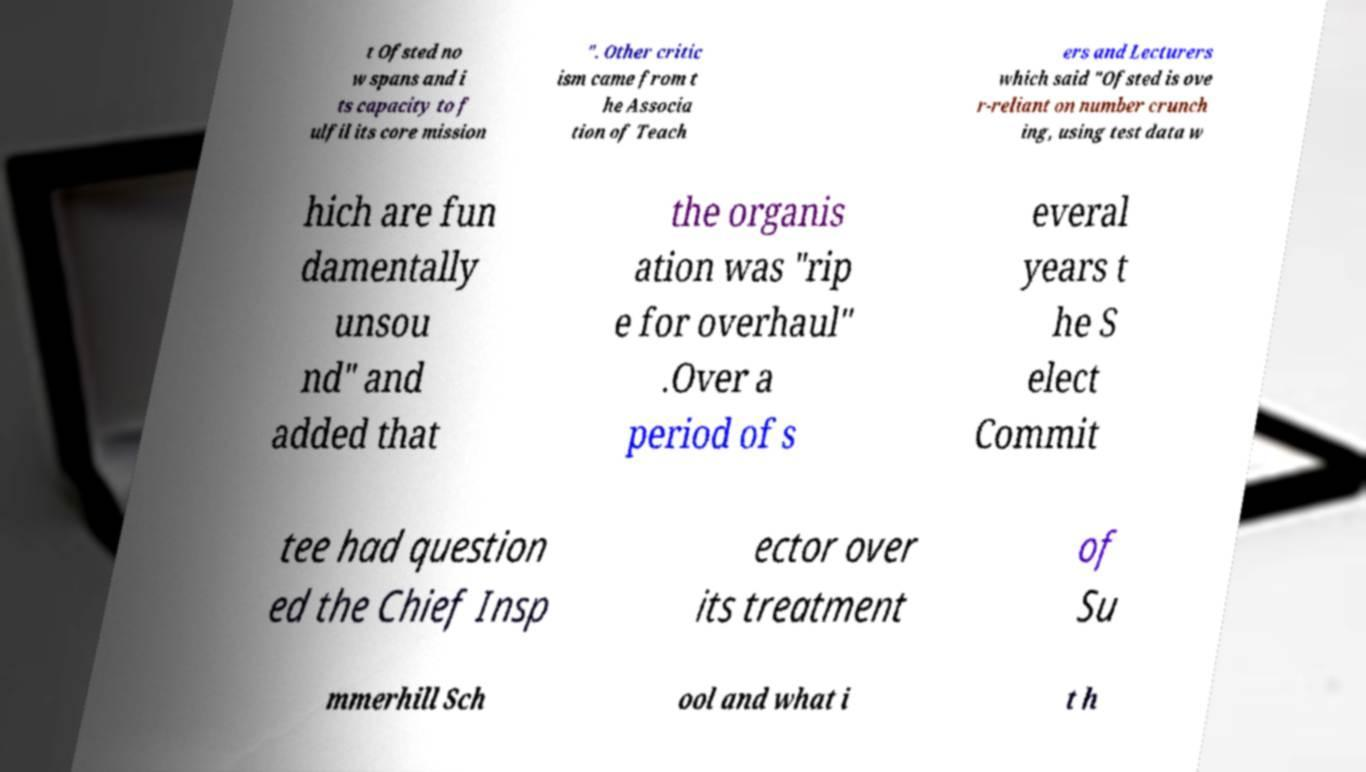Could you assist in decoding the text presented in this image and type it out clearly? t Ofsted no w spans and i ts capacity to f ulfil its core mission ". Other critic ism came from t he Associa tion of Teach ers and Lecturers which said "Ofsted is ove r-reliant on number crunch ing, using test data w hich are fun damentally unsou nd" and added that the organis ation was "rip e for overhaul" .Over a period of s everal years t he S elect Commit tee had question ed the Chief Insp ector over its treatment of Su mmerhill Sch ool and what i t h 